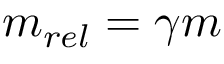Convert formula to latex. <formula><loc_0><loc_0><loc_500><loc_500>m _ { r e l } = \gamma m</formula> 